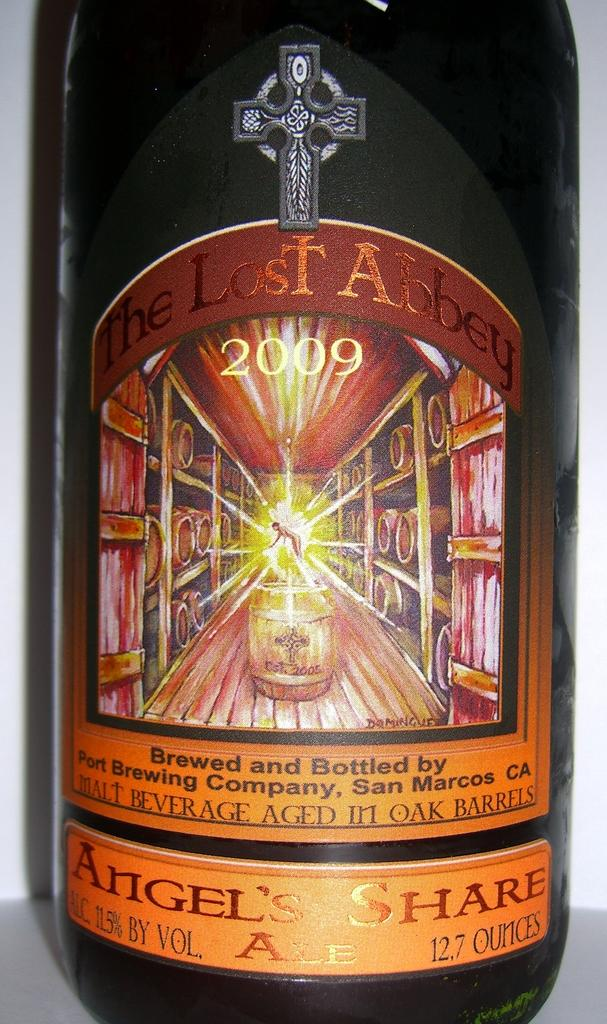<image>
Share a concise interpretation of the image provided. A bottle of 2009 The Lost Abbey is 12.7 ounces. 